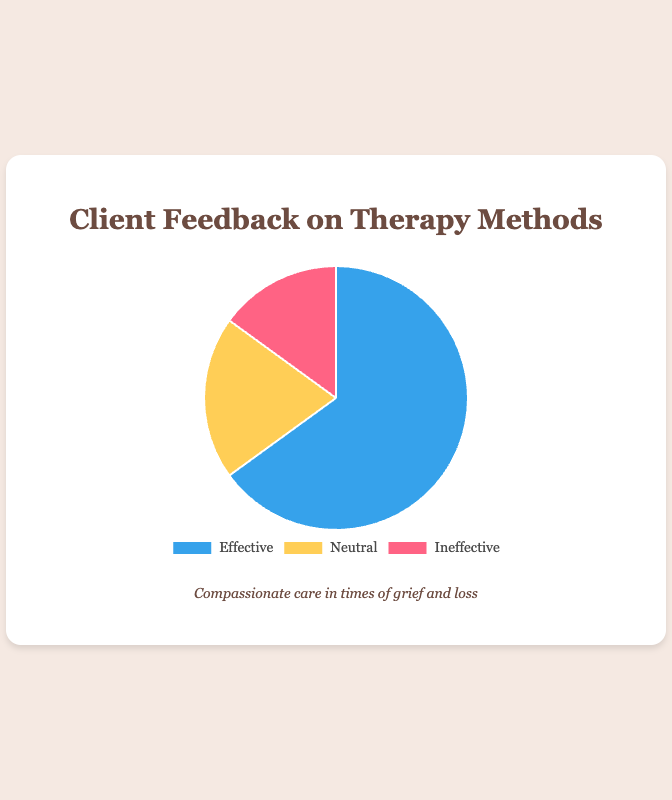What are the percentages for each feedback category? The pie chart will show three sections with different colors representing "Effective", "Neutral", and "Ineffective". By looking at the sections and their corresponding labels, we can see that "Effective" makes up 65%, "Neutral" is 20%, and "Ineffective" is 15%.
Answer: Effective: 65%, Neutral: 20%, Ineffective: 15% Which feedback category received the highest percentage? We compare the percentages for each category visible in the chart. The category "Effective" has the highest percentage at 65%, compared to "Neutral" at 20% and "Ineffective" at 15%.
Answer: Effective What is the difference in percentage between "Effective" and "Neutral" feedback? To find the difference, subtract the percentage of "Neutral" feedback from the percentage of "Effective" feedback: 65% - 20% = 45%.
Answer: 45% How much more percentage did "Effective" feedback receive compared to "Ineffective" feedback? Subtract the percentage of "Ineffective" feedback from the percentage of "Effective" feedback: 65% - 15% = 50%.
Answer: 50% What fraction of the total feedback is "Neutral"? To convert the percentage of "Neutral" feedback to a fraction, divide 20 by 100: 20/100 = 1/5.
Answer: 1/5 Which section of the pie chart is represented by the color blue? By examining the colors associated with each feedback category, we see that "Effective" is represented by blue.
Answer: Effective If we combine "Neutral" and "Ineffective" feedback, what is their total percentage? Add the percentages of "Neutral" and "Ineffective" feedback: 20% + 15% = 35%.
Answer: 35% How does the size of the "Ineffective" section compare to the "Neutral" section in the chart? By comparing the two sections visible on the chart, we see that "Neutral" at 20% is larger than "Ineffective" at 15%.
Answer: Neutral is larger What percentage of feedback was not "Effective"? To find the percentage of feedback that is not "Effective", add the percentages of "Neutral" and "Ineffective": 20% + 15% = 35%.
Answer: 35% Which category received the least feedback? By comparing the percentages of each category, we see that "Ineffective" received the smallest percentage at 15%.
Answer: Ineffective 